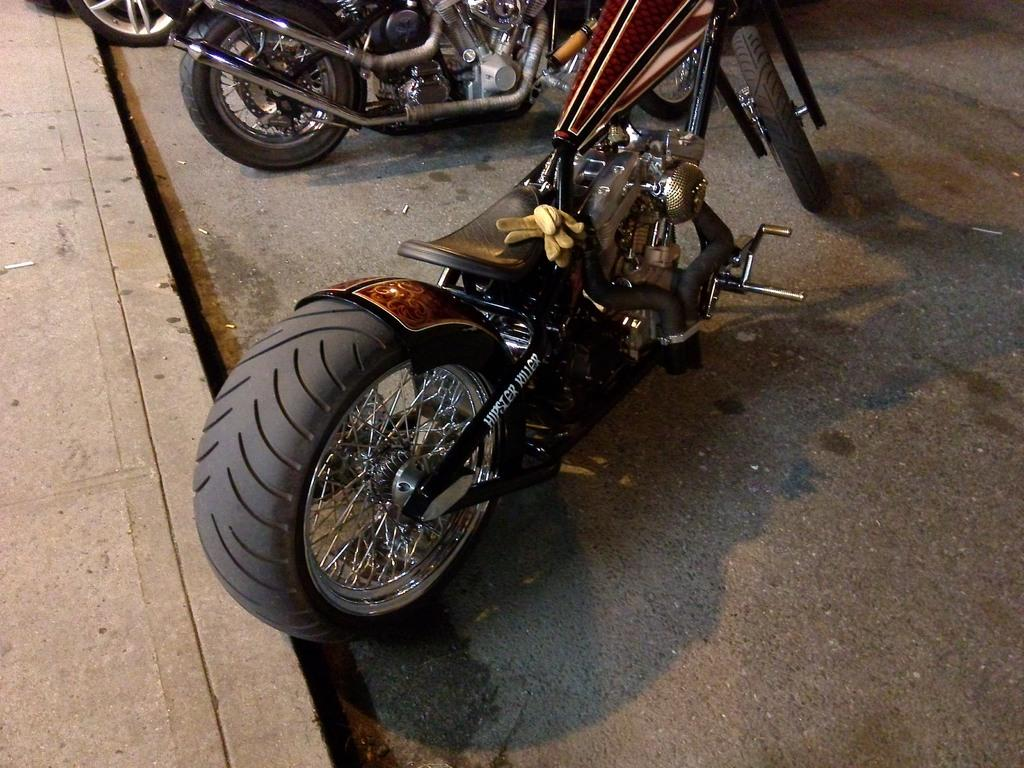What can be seen on the road in the image? There are vehicles parked on the road in the image. What is located on the left side of the image? There is a walkway on the left side of the image. What type of plough is being used on the walkway in the image? There is no plough present in the image; it features vehicles parked on the road and a walkway on the left side. How many rings can be seen on the vehicles in the image? There is no mention of rings on the vehicles in the image, so it cannot be determined from the provided facts. 